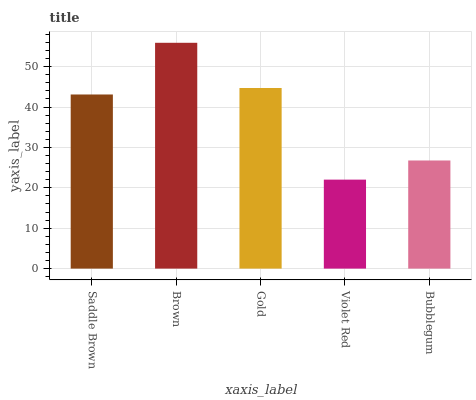Is Violet Red the minimum?
Answer yes or no. Yes. Is Brown the maximum?
Answer yes or no. Yes. Is Gold the minimum?
Answer yes or no. No. Is Gold the maximum?
Answer yes or no. No. Is Brown greater than Gold?
Answer yes or no. Yes. Is Gold less than Brown?
Answer yes or no. Yes. Is Gold greater than Brown?
Answer yes or no. No. Is Brown less than Gold?
Answer yes or no. No. Is Saddle Brown the high median?
Answer yes or no. Yes. Is Saddle Brown the low median?
Answer yes or no. Yes. Is Bubblegum the high median?
Answer yes or no. No. Is Gold the low median?
Answer yes or no. No. 